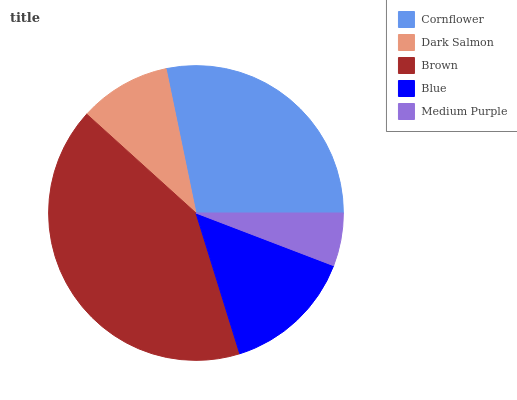Is Medium Purple the minimum?
Answer yes or no. Yes. Is Brown the maximum?
Answer yes or no. Yes. Is Dark Salmon the minimum?
Answer yes or no. No. Is Dark Salmon the maximum?
Answer yes or no. No. Is Cornflower greater than Dark Salmon?
Answer yes or no. Yes. Is Dark Salmon less than Cornflower?
Answer yes or no. Yes. Is Dark Salmon greater than Cornflower?
Answer yes or no. No. Is Cornflower less than Dark Salmon?
Answer yes or no. No. Is Blue the high median?
Answer yes or no. Yes. Is Blue the low median?
Answer yes or no. Yes. Is Dark Salmon the high median?
Answer yes or no. No. Is Brown the low median?
Answer yes or no. No. 